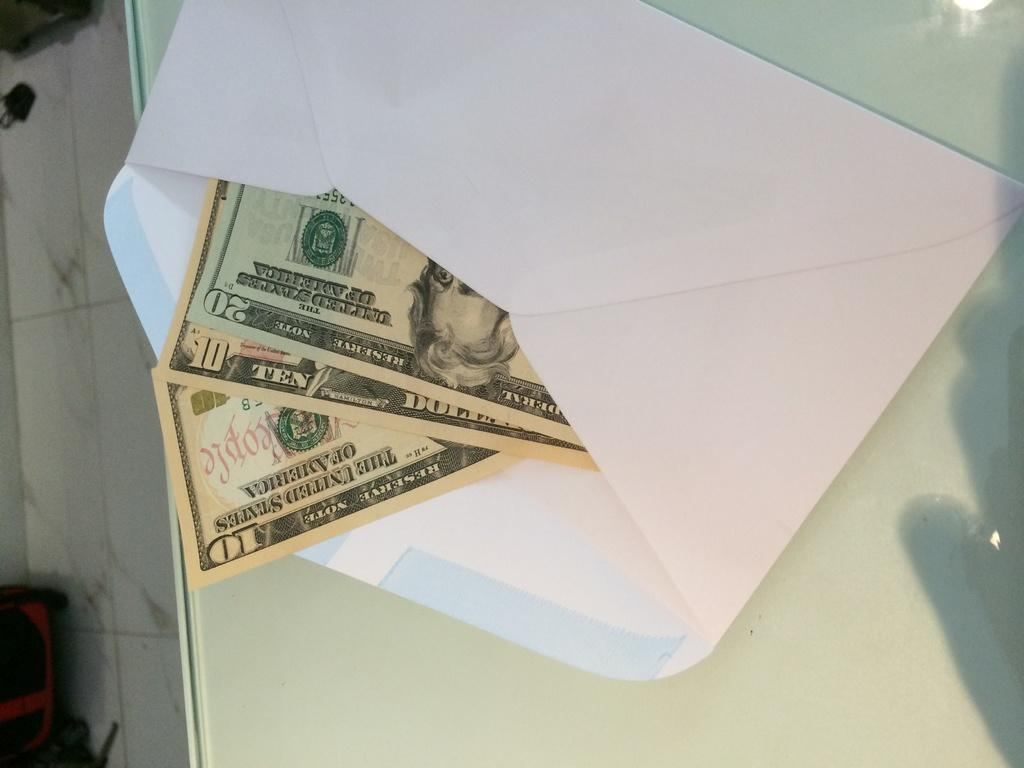<image>
Provide a brief description of the given image. A 10 and 20 dollar note in an envelope. 